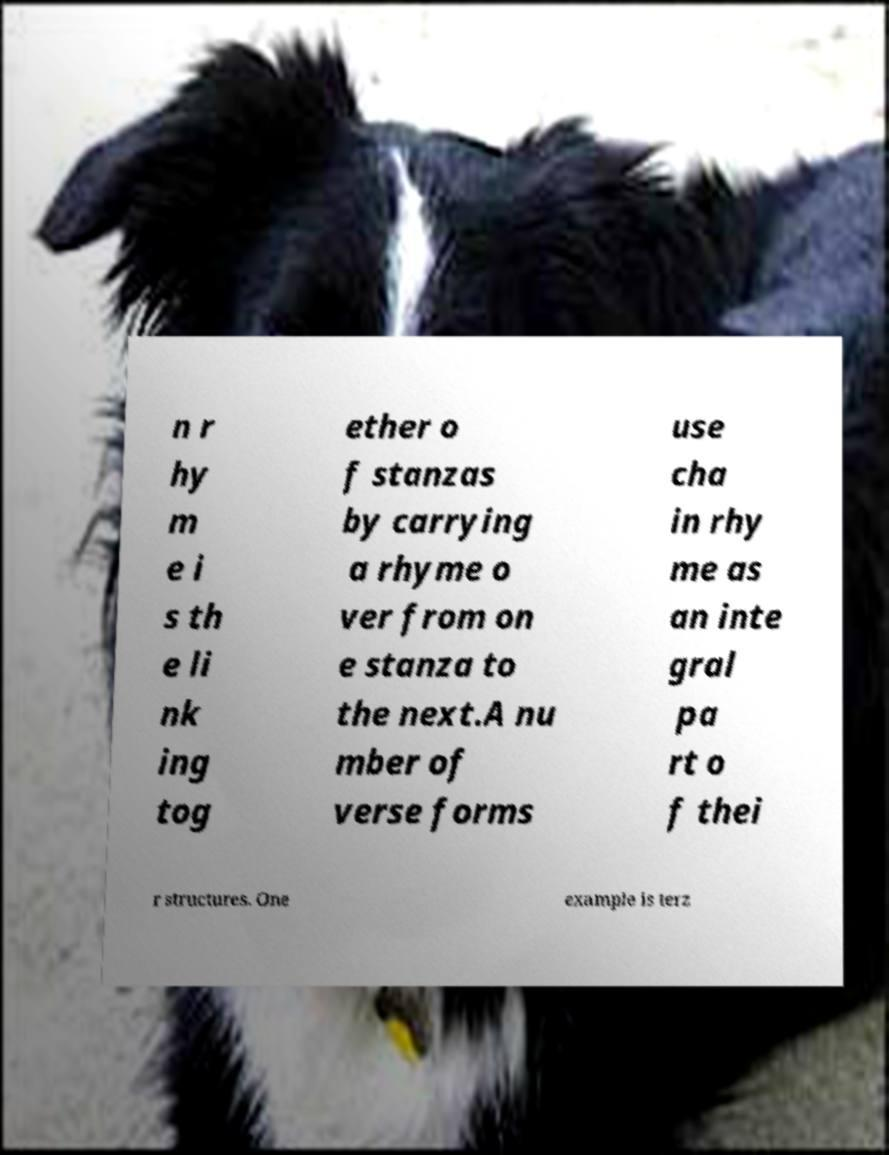Can you accurately transcribe the text from the provided image for me? n r hy m e i s th e li nk ing tog ether o f stanzas by carrying a rhyme o ver from on e stanza to the next.A nu mber of verse forms use cha in rhy me as an inte gral pa rt o f thei r structures. One example is terz 